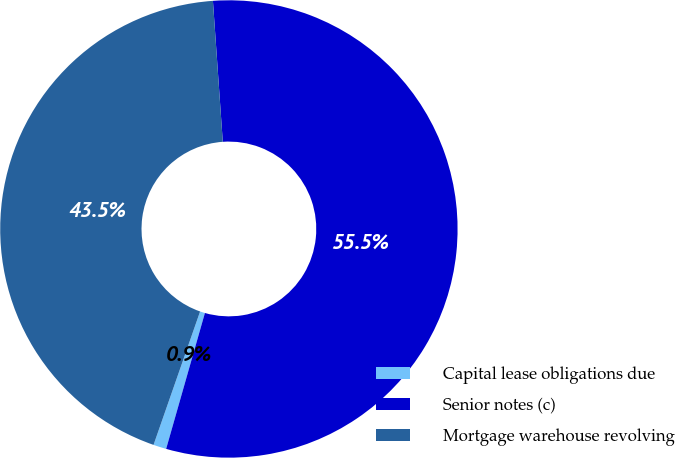<chart> <loc_0><loc_0><loc_500><loc_500><pie_chart><fcel>Capital lease obligations due<fcel>Senior notes (c)<fcel>Mortgage warehouse revolving<nl><fcel>0.92%<fcel>55.53%<fcel>43.54%<nl></chart> 